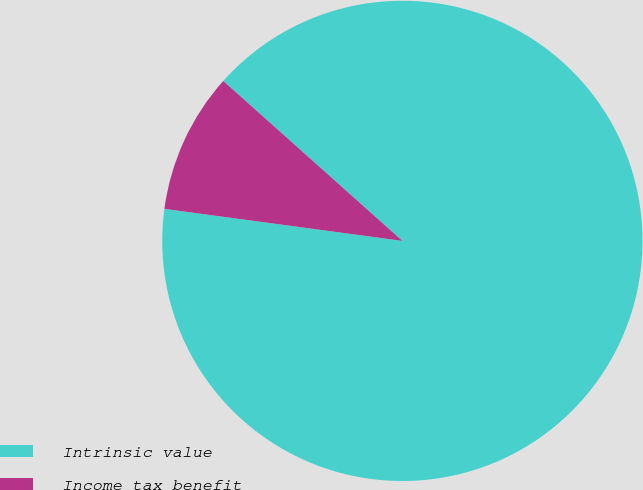Convert chart. <chart><loc_0><loc_0><loc_500><loc_500><pie_chart><fcel>Intrinsic value<fcel>Income tax benefit<nl><fcel>90.53%<fcel>9.47%<nl></chart> 